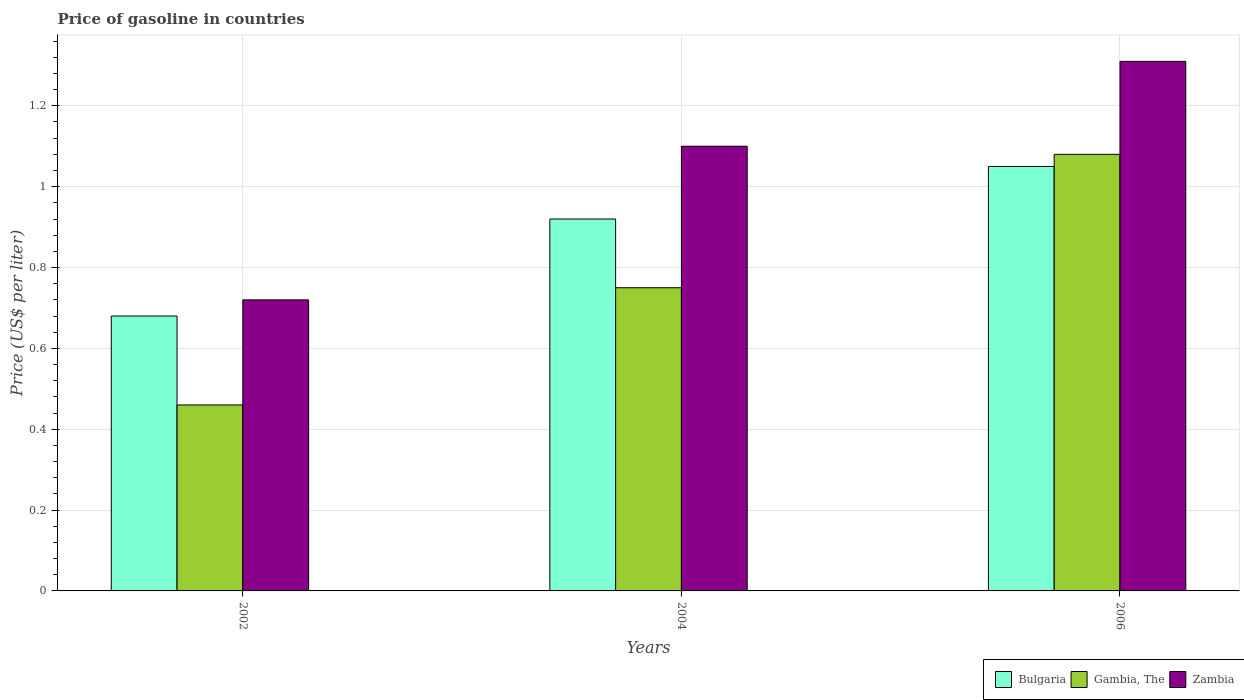How many groups of bars are there?
Ensure brevity in your answer.  3. Are the number of bars per tick equal to the number of legend labels?
Your response must be concise. Yes. How many bars are there on the 2nd tick from the right?
Keep it short and to the point. 3. What is the label of the 2nd group of bars from the left?
Ensure brevity in your answer.  2004. In how many cases, is the number of bars for a given year not equal to the number of legend labels?
Provide a succinct answer. 0. What is the price of gasoline in Bulgaria in 2006?
Make the answer very short. 1.05. Across all years, what is the maximum price of gasoline in Gambia, The?
Keep it short and to the point. 1.08. Across all years, what is the minimum price of gasoline in Gambia, The?
Offer a terse response. 0.46. In which year was the price of gasoline in Bulgaria minimum?
Keep it short and to the point. 2002. What is the total price of gasoline in Bulgaria in the graph?
Offer a terse response. 2.65. What is the difference between the price of gasoline in Bulgaria in 2002 and that in 2004?
Provide a succinct answer. -0.24. What is the difference between the price of gasoline in Bulgaria in 2006 and the price of gasoline in Zambia in 2002?
Your response must be concise. 0.33. What is the average price of gasoline in Gambia, The per year?
Ensure brevity in your answer.  0.76. In the year 2006, what is the difference between the price of gasoline in Zambia and price of gasoline in Bulgaria?
Give a very brief answer. 0.26. In how many years, is the price of gasoline in Zambia greater than 0.7200000000000001 US$?
Ensure brevity in your answer.  2. What is the ratio of the price of gasoline in Gambia, The in 2004 to that in 2006?
Offer a terse response. 0.69. Is the price of gasoline in Zambia in 2004 less than that in 2006?
Offer a very short reply. Yes. Is the difference between the price of gasoline in Zambia in 2002 and 2006 greater than the difference between the price of gasoline in Bulgaria in 2002 and 2006?
Provide a succinct answer. No. What is the difference between the highest and the second highest price of gasoline in Zambia?
Your answer should be compact. 0.21. What is the difference between the highest and the lowest price of gasoline in Bulgaria?
Make the answer very short. 0.37. What does the 1st bar from the right in 2002 represents?
Your answer should be compact. Zambia. Are all the bars in the graph horizontal?
Provide a short and direct response. No. How many years are there in the graph?
Provide a succinct answer. 3. What is the difference between two consecutive major ticks on the Y-axis?
Provide a short and direct response. 0.2. Are the values on the major ticks of Y-axis written in scientific E-notation?
Provide a succinct answer. No. Does the graph contain any zero values?
Offer a very short reply. No. Where does the legend appear in the graph?
Provide a succinct answer. Bottom right. How many legend labels are there?
Provide a succinct answer. 3. How are the legend labels stacked?
Ensure brevity in your answer.  Horizontal. What is the title of the graph?
Make the answer very short. Price of gasoline in countries. What is the label or title of the X-axis?
Give a very brief answer. Years. What is the label or title of the Y-axis?
Your response must be concise. Price (US$ per liter). What is the Price (US$ per liter) of Bulgaria in 2002?
Make the answer very short. 0.68. What is the Price (US$ per liter) of Gambia, The in 2002?
Ensure brevity in your answer.  0.46. What is the Price (US$ per liter) of Zambia in 2002?
Your answer should be compact. 0.72. What is the Price (US$ per liter) of Gambia, The in 2004?
Offer a very short reply. 0.75. What is the Price (US$ per liter) in Bulgaria in 2006?
Ensure brevity in your answer.  1.05. What is the Price (US$ per liter) in Zambia in 2006?
Give a very brief answer. 1.31. Across all years, what is the maximum Price (US$ per liter) of Bulgaria?
Give a very brief answer. 1.05. Across all years, what is the maximum Price (US$ per liter) of Zambia?
Ensure brevity in your answer.  1.31. Across all years, what is the minimum Price (US$ per liter) of Bulgaria?
Provide a short and direct response. 0.68. Across all years, what is the minimum Price (US$ per liter) of Gambia, The?
Your response must be concise. 0.46. Across all years, what is the minimum Price (US$ per liter) of Zambia?
Your response must be concise. 0.72. What is the total Price (US$ per liter) in Bulgaria in the graph?
Keep it short and to the point. 2.65. What is the total Price (US$ per liter) of Gambia, The in the graph?
Your answer should be compact. 2.29. What is the total Price (US$ per liter) in Zambia in the graph?
Keep it short and to the point. 3.13. What is the difference between the Price (US$ per liter) of Bulgaria in 2002 and that in 2004?
Your response must be concise. -0.24. What is the difference between the Price (US$ per liter) of Gambia, The in 2002 and that in 2004?
Give a very brief answer. -0.29. What is the difference between the Price (US$ per liter) of Zambia in 2002 and that in 2004?
Your response must be concise. -0.38. What is the difference between the Price (US$ per liter) of Bulgaria in 2002 and that in 2006?
Your answer should be compact. -0.37. What is the difference between the Price (US$ per liter) of Gambia, The in 2002 and that in 2006?
Provide a succinct answer. -0.62. What is the difference between the Price (US$ per liter) of Zambia in 2002 and that in 2006?
Offer a very short reply. -0.59. What is the difference between the Price (US$ per liter) in Bulgaria in 2004 and that in 2006?
Give a very brief answer. -0.13. What is the difference between the Price (US$ per liter) in Gambia, The in 2004 and that in 2006?
Ensure brevity in your answer.  -0.33. What is the difference between the Price (US$ per liter) in Zambia in 2004 and that in 2006?
Provide a short and direct response. -0.21. What is the difference between the Price (US$ per liter) in Bulgaria in 2002 and the Price (US$ per liter) in Gambia, The in 2004?
Keep it short and to the point. -0.07. What is the difference between the Price (US$ per liter) of Bulgaria in 2002 and the Price (US$ per liter) of Zambia in 2004?
Offer a terse response. -0.42. What is the difference between the Price (US$ per liter) of Gambia, The in 2002 and the Price (US$ per liter) of Zambia in 2004?
Offer a very short reply. -0.64. What is the difference between the Price (US$ per liter) in Bulgaria in 2002 and the Price (US$ per liter) in Gambia, The in 2006?
Provide a short and direct response. -0.4. What is the difference between the Price (US$ per liter) in Bulgaria in 2002 and the Price (US$ per liter) in Zambia in 2006?
Keep it short and to the point. -0.63. What is the difference between the Price (US$ per liter) in Gambia, The in 2002 and the Price (US$ per liter) in Zambia in 2006?
Provide a short and direct response. -0.85. What is the difference between the Price (US$ per liter) of Bulgaria in 2004 and the Price (US$ per liter) of Gambia, The in 2006?
Give a very brief answer. -0.16. What is the difference between the Price (US$ per liter) of Bulgaria in 2004 and the Price (US$ per liter) of Zambia in 2006?
Provide a short and direct response. -0.39. What is the difference between the Price (US$ per liter) in Gambia, The in 2004 and the Price (US$ per liter) in Zambia in 2006?
Make the answer very short. -0.56. What is the average Price (US$ per liter) in Bulgaria per year?
Your response must be concise. 0.88. What is the average Price (US$ per liter) of Gambia, The per year?
Provide a short and direct response. 0.76. What is the average Price (US$ per liter) of Zambia per year?
Give a very brief answer. 1.04. In the year 2002, what is the difference between the Price (US$ per liter) in Bulgaria and Price (US$ per liter) in Gambia, The?
Your response must be concise. 0.22. In the year 2002, what is the difference between the Price (US$ per liter) of Bulgaria and Price (US$ per liter) of Zambia?
Provide a succinct answer. -0.04. In the year 2002, what is the difference between the Price (US$ per liter) of Gambia, The and Price (US$ per liter) of Zambia?
Give a very brief answer. -0.26. In the year 2004, what is the difference between the Price (US$ per liter) of Bulgaria and Price (US$ per liter) of Gambia, The?
Keep it short and to the point. 0.17. In the year 2004, what is the difference between the Price (US$ per liter) in Bulgaria and Price (US$ per liter) in Zambia?
Offer a terse response. -0.18. In the year 2004, what is the difference between the Price (US$ per liter) of Gambia, The and Price (US$ per liter) of Zambia?
Offer a terse response. -0.35. In the year 2006, what is the difference between the Price (US$ per liter) in Bulgaria and Price (US$ per liter) in Gambia, The?
Provide a succinct answer. -0.03. In the year 2006, what is the difference between the Price (US$ per liter) of Bulgaria and Price (US$ per liter) of Zambia?
Make the answer very short. -0.26. In the year 2006, what is the difference between the Price (US$ per liter) of Gambia, The and Price (US$ per liter) of Zambia?
Your answer should be very brief. -0.23. What is the ratio of the Price (US$ per liter) in Bulgaria in 2002 to that in 2004?
Your response must be concise. 0.74. What is the ratio of the Price (US$ per liter) of Gambia, The in 2002 to that in 2004?
Offer a very short reply. 0.61. What is the ratio of the Price (US$ per liter) in Zambia in 2002 to that in 2004?
Keep it short and to the point. 0.65. What is the ratio of the Price (US$ per liter) in Bulgaria in 2002 to that in 2006?
Your answer should be compact. 0.65. What is the ratio of the Price (US$ per liter) in Gambia, The in 2002 to that in 2006?
Your answer should be very brief. 0.43. What is the ratio of the Price (US$ per liter) of Zambia in 2002 to that in 2006?
Offer a very short reply. 0.55. What is the ratio of the Price (US$ per liter) in Bulgaria in 2004 to that in 2006?
Give a very brief answer. 0.88. What is the ratio of the Price (US$ per liter) of Gambia, The in 2004 to that in 2006?
Keep it short and to the point. 0.69. What is the ratio of the Price (US$ per liter) in Zambia in 2004 to that in 2006?
Ensure brevity in your answer.  0.84. What is the difference between the highest and the second highest Price (US$ per liter) in Bulgaria?
Your answer should be compact. 0.13. What is the difference between the highest and the second highest Price (US$ per liter) of Gambia, The?
Give a very brief answer. 0.33. What is the difference between the highest and the second highest Price (US$ per liter) of Zambia?
Offer a terse response. 0.21. What is the difference between the highest and the lowest Price (US$ per liter) of Bulgaria?
Make the answer very short. 0.37. What is the difference between the highest and the lowest Price (US$ per liter) of Gambia, The?
Ensure brevity in your answer.  0.62. What is the difference between the highest and the lowest Price (US$ per liter) of Zambia?
Offer a very short reply. 0.59. 